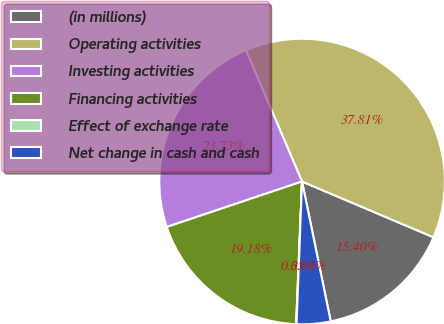<chart> <loc_0><loc_0><loc_500><loc_500><pie_chart><fcel>(in millions)<fcel>Operating activities<fcel>Investing activities<fcel>Financing activities<fcel>Effect of exchange rate<fcel>Net change in cash and cash<nl><fcel>15.4%<fcel>37.81%<fcel>23.73%<fcel>19.18%<fcel>0.05%<fcel>3.83%<nl></chart> 